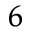Convert formula to latex. <formula><loc_0><loc_0><loc_500><loc_500>^ { 6 }</formula> 